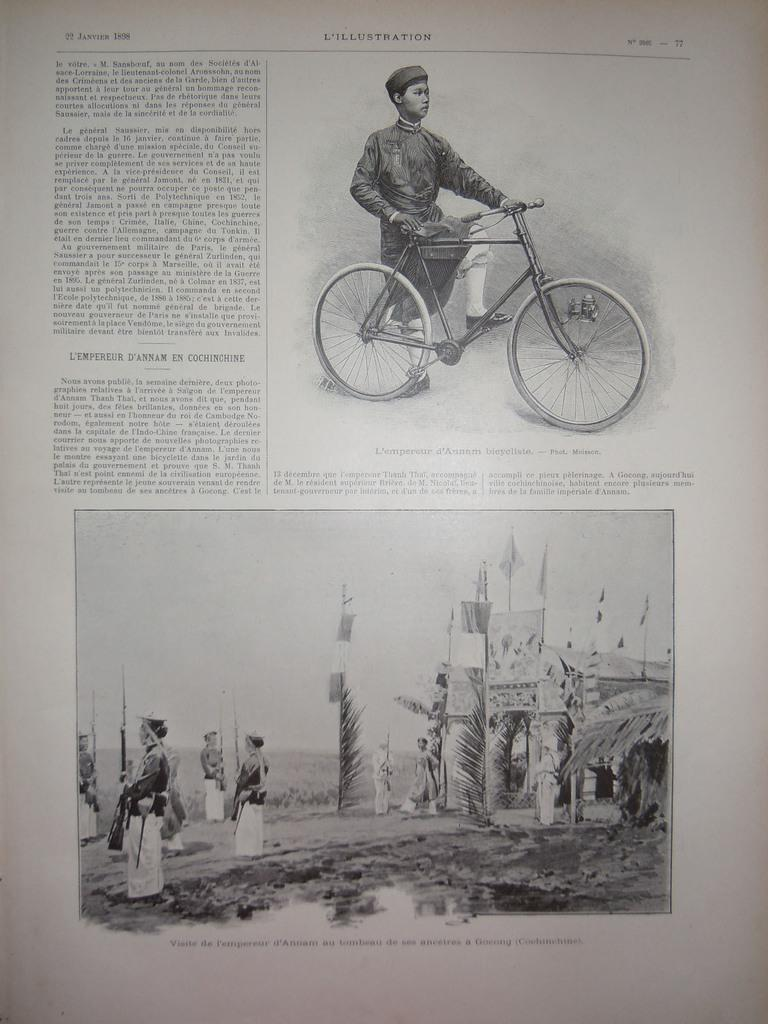What is depicted on the paper in the image? There are pictures of people on the paper. Can you describe one of the pictures in more detail? In one of the pictures, a man is holding a bicycle. What else can be seen on the paper besides the pictures? There is writing on the paper. How many screws can be seen in the picture of the man holding a bicycle? There are no screws visible in the picture of the man holding a bicycle. What type of rings are the boys wearing in the image? There are no boys present in the image, so it is not possible to determine if they are wearing any rings. 